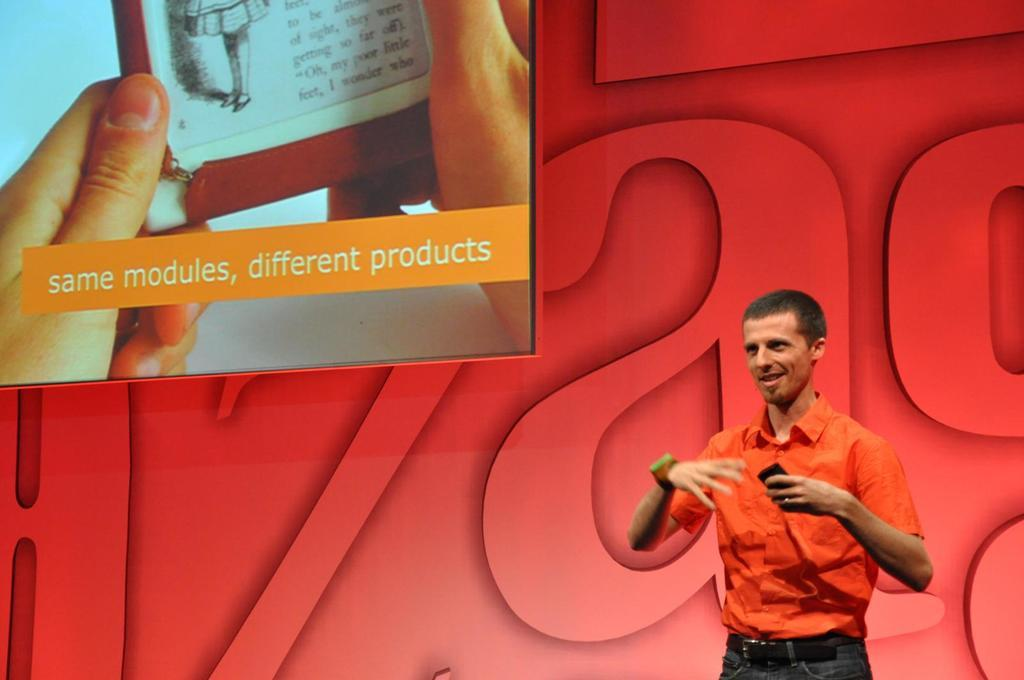<image>
Write a terse but informative summary of the picture. A man giving a speech with a blowup behind him that says same modules, different products. 